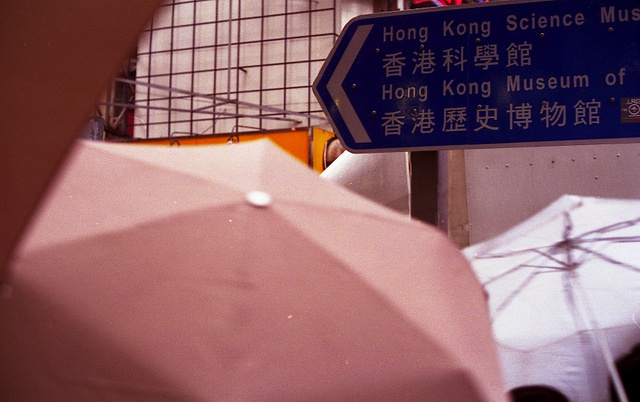Describe the objects in this image and their specific colors. I can see umbrella in maroon, brown, lightpink, and lightgray tones and umbrella in maroon, lavender, darkgray, pink, and gray tones in this image. 